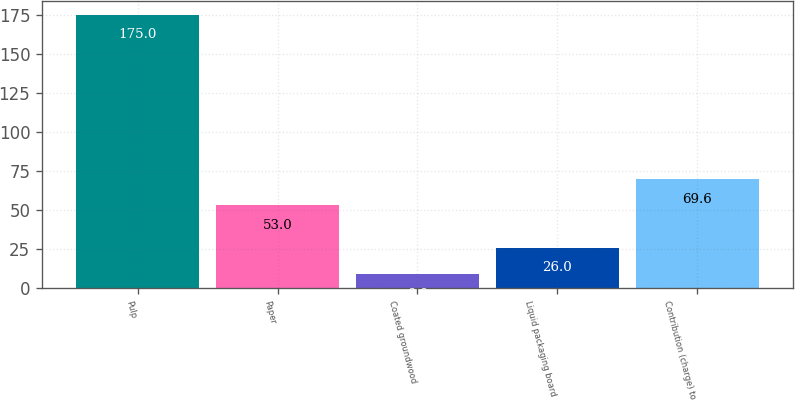Convert chart. <chart><loc_0><loc_0><loc_500><loc_500><bar_chart><fcel>Pulp<fcel>Paper<fcel>Coated groundwood<fcel>Liquid packaging board<fcel>Contribution (charge) to<nl><fcel>175<fcel>53<fcel>9<fcel>26<fcel>69.6<nl></chart> 